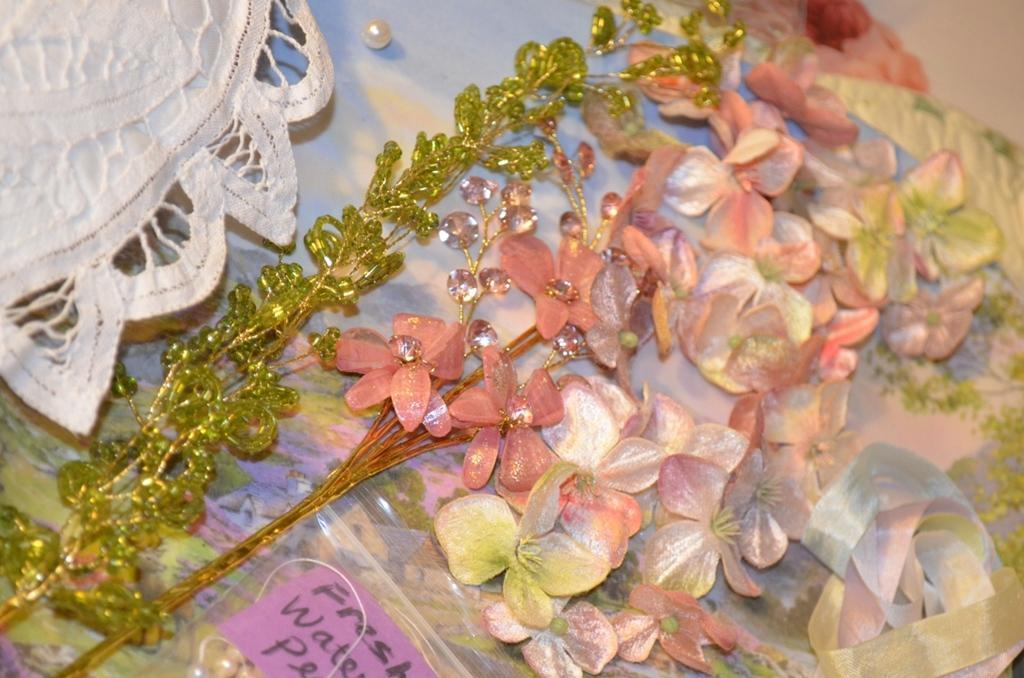Can you describe this image briefly? These are flowers, this is pink color paper. 